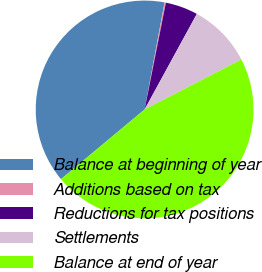Convert chart to OTSL. <chart><loc_0><loc_0><loc_500><loc_500><pie_chart><fcel>Balance at beginning of year<fcel>Additions based on tax<fcel>Reductions for tax positions<fcel>Settlements<fcel>Balance at end of year<nl><fcel>38.99%<fcel>0.2%<fcel>4.83%<fcel>9.46%<fcel>46.52%<nl></chart> 